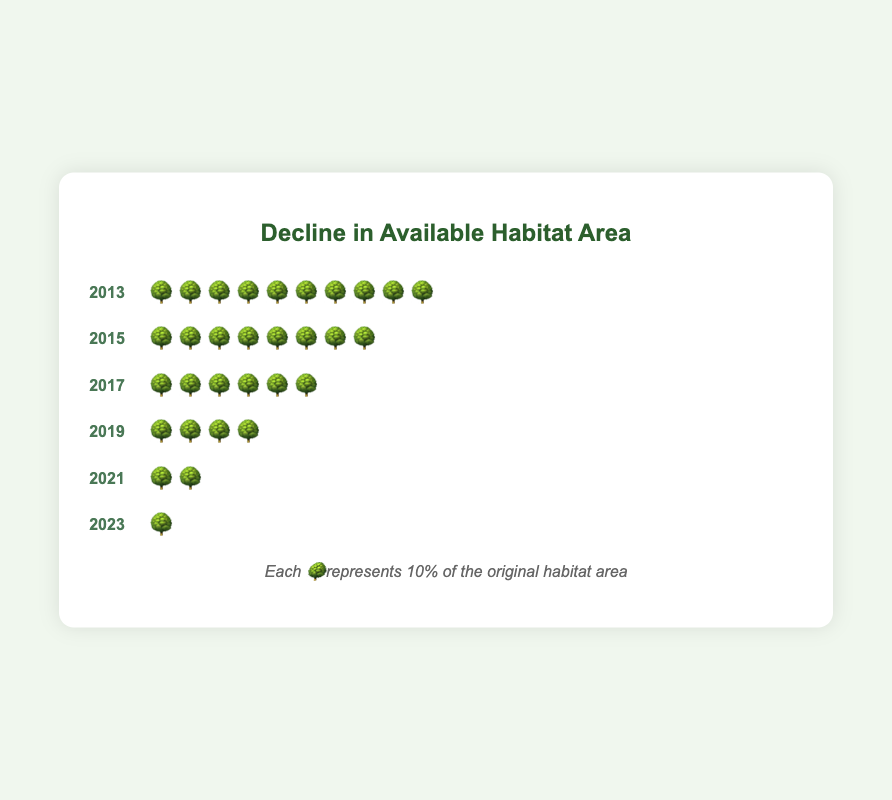What is the title of the chart? The chart's title is prominently displayed at the top of the chart container. By looking at the top section, you can see the big and clear text that states "Decline in Available Habitat Area".
Answer: Decline in Available Habitat Area How many tree emojis represent the habitat area in 2015? By looking at the chart row labeled with the year 2015, you will see a sequence of tree emojis. Counting these tree emojis gives the total number present in that year.
Answer: 8 Which year had the highest number of tree emojis? By checking all the chart rows and counting the tree emojis for each year, the year with the highest count of emojis is identified. In this case, 2013 has the highest with 10 emojis.
Answer: 2013 How many tree emojis were lost between 2017 and 2021? First, count the tree emojis for 2017, which are 6. Then, count the tree emojis for 2021, which are 2. Subtract the number of emojis in 2021 from those in 2017 to find the loss. 6 - 2 = 4.
Answer: 4 Which two consecutive years show the greatest decline in habitat area? Compare the number of tree emojis year-by-year to determine the difference between consecutive years. The greatest difference is between 2019 (4) and 2021 (2). 4 - 2 = 2.
Answer: 2019-2021 How many tree emojis are there in total across all years? To find the total number of tree emojis, count the emojis in each year and add them together: 10 (2013) + 8 (2015) + 6 (2017) + 4 (2019) + 2 (2021) + 1 (2023) = 31.
Answer: 31 By how much did the number of tree emojis change from 2013 to 2023? Count the tree emojis in 2013, which is 10. Count the tree emojis in 2023, which is 1. Subtract the number in 2023 from the number in 2013 to calculate the change: 10 - 1 = 9.
Answer: 9 What is the average number of tree emojis per year? First, sum up all the tree emojis: 31. Then, divide by the number of years (6): 31 / 6 ≈ 5.17.
Answer: 5.17 Which year saw a reduction of 2 tree emojis in the habitat area? By looking at the rows, observe the yearly change in the number of tree emojis. The years where the difference is exactly 2 are: from 2015 to 2017 (8 to 6), and from 2019 to 2021 (4 to 2).
Answer: 2015-2017 and 2019-2021 